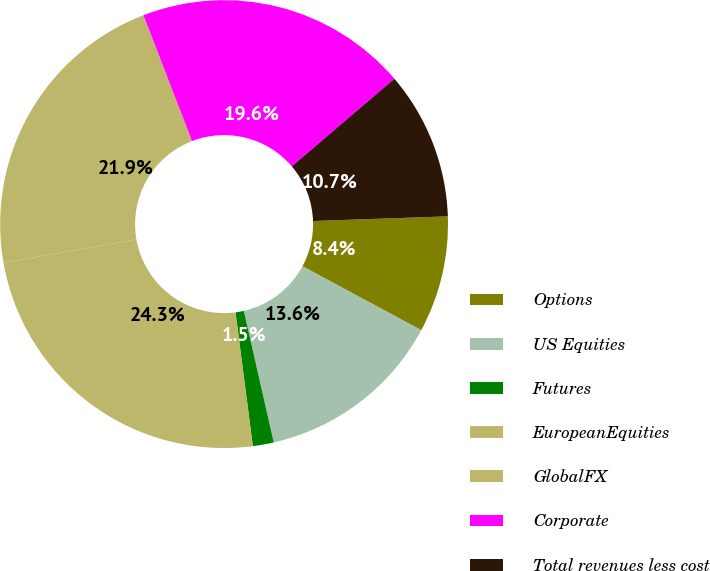Convert chart to OTSL. <chart><loc_0><loc_0><loc_500><loc_500><pie_chart><fcel>Options<fcel>US Equities<fcel>Futures<fcel>EuropeanEquities<fcel>GlobalFX<fcel>Corporate<fcel>Total revenues less cost<nl><fcel>8.41%<fcel>13.58%<fcel>1.51%<fcel>24.28%<fcel>21.9%<fcel>19.62%<fcel>10.69%<nl></chart> 